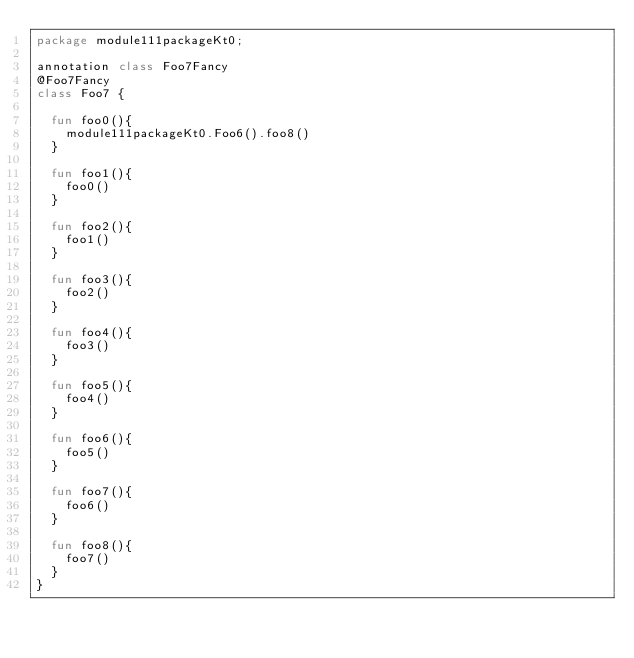Convert code to text. <code><loc_0><loc_0><loc_500><loc_500><_Kotlin_>package module111packageKt0;

annotation class Foo7Fancy
@Foo7Fancy
class Foo7 {

  fun foo0(){
    module111packageKt0.Foo6().foo8()
  }

  fun foo1(){
    foo0()
  }

  fun foo2(){
    foo1()
  }

  fun foo3(){
    foo2()
  }

  fun foo4(){
    foo3()
  }

  fun foo5(){
    foo4()
  }

  fun foo6(){
    foo5()
  }

  fun foo7(){
    foo6()
  }

  fun foo8(){
    foo7()
  }
}</code> 